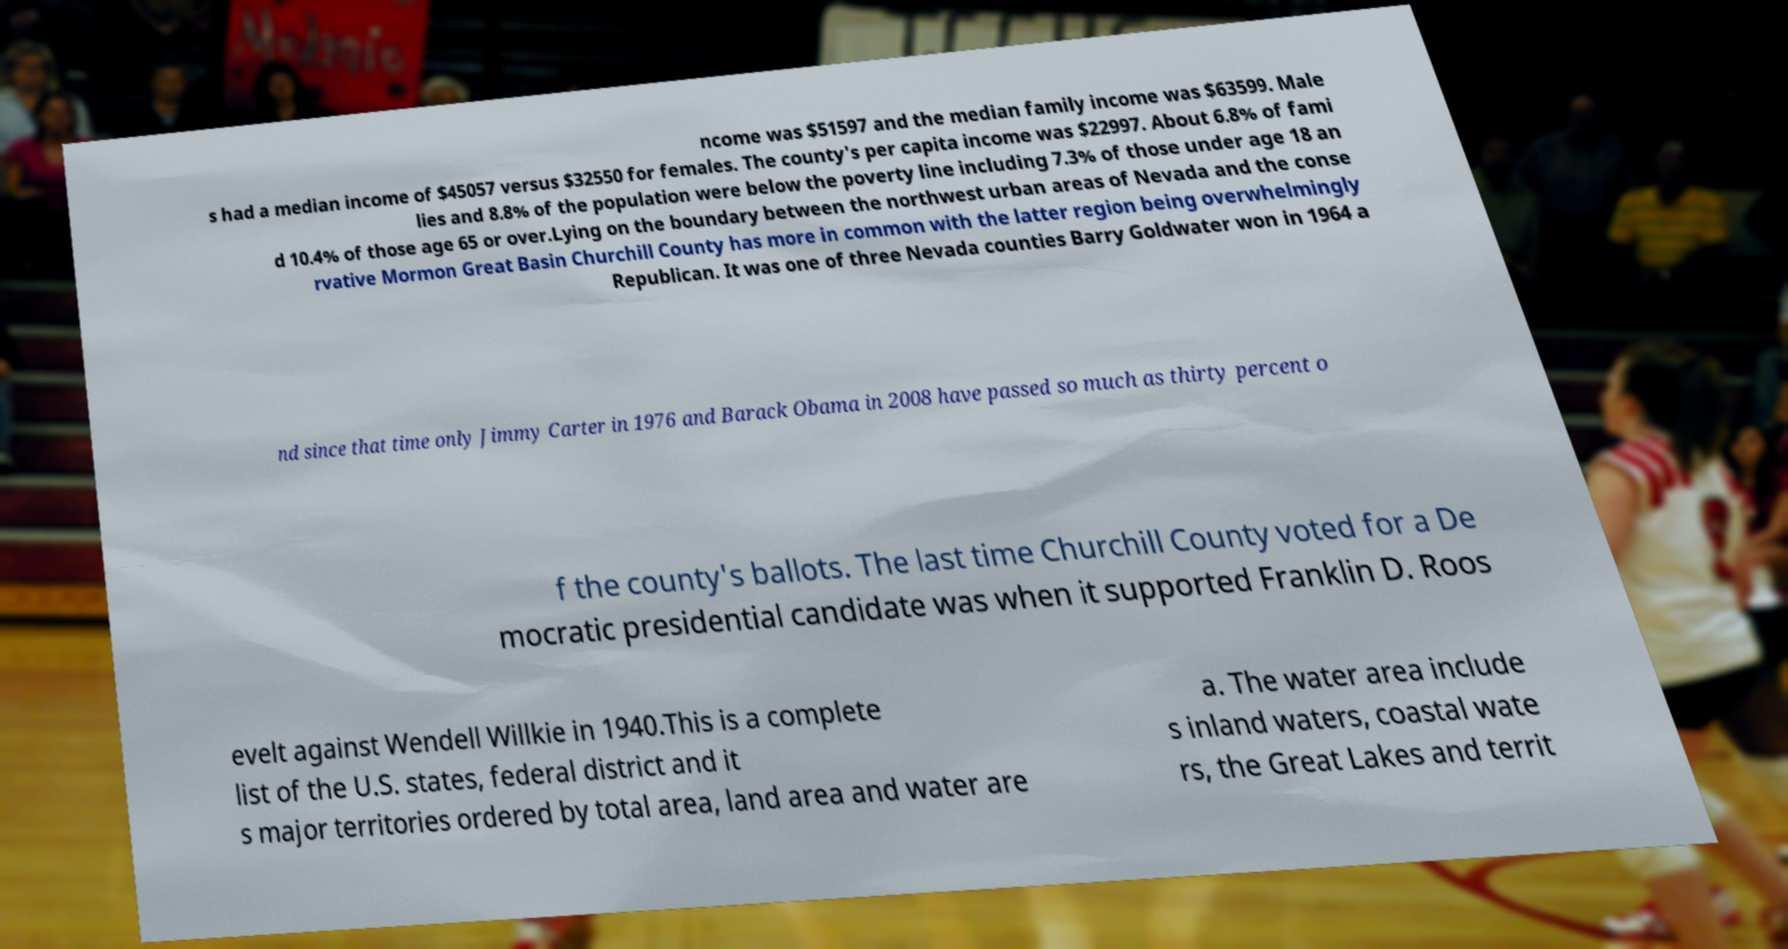Could you assist in decoding the text presented in this image and type it out clearly? ncome was $51597 and the median family income was $63599. Male s had a median income of $45057 versus $32550 for females. The county's per capita income was $22997. About 6.8% of fami lies and 8.8% of the population were below the poverty line including 7.3% of those under age 18 an d 10.4% of those age 65 or over.Lying on the boundary between the northwest urban areas of Nevada and the conse rvative Mormon Great Basin Churchill County has more in common with the latter region being overwhelmingly Republican. It was one of three Nevada counties Barry Goldwater won in 1964 a nd since that time only Jimmy Carter in 1976 and Barack Obama in 2008 have passed so much as thirty percent o f the county's ballots. The last time Churchill County voted for a De mocratic presidential candidate was when it supported Franklin D. Roos evelt against Wendell Willkie in 1940.This is a complete list of the U.S. states, federal district and it s major territories ordered by total area, land area and water are a. The water area include s inland waters, coastal wate rs, the Great Lakes and territ 